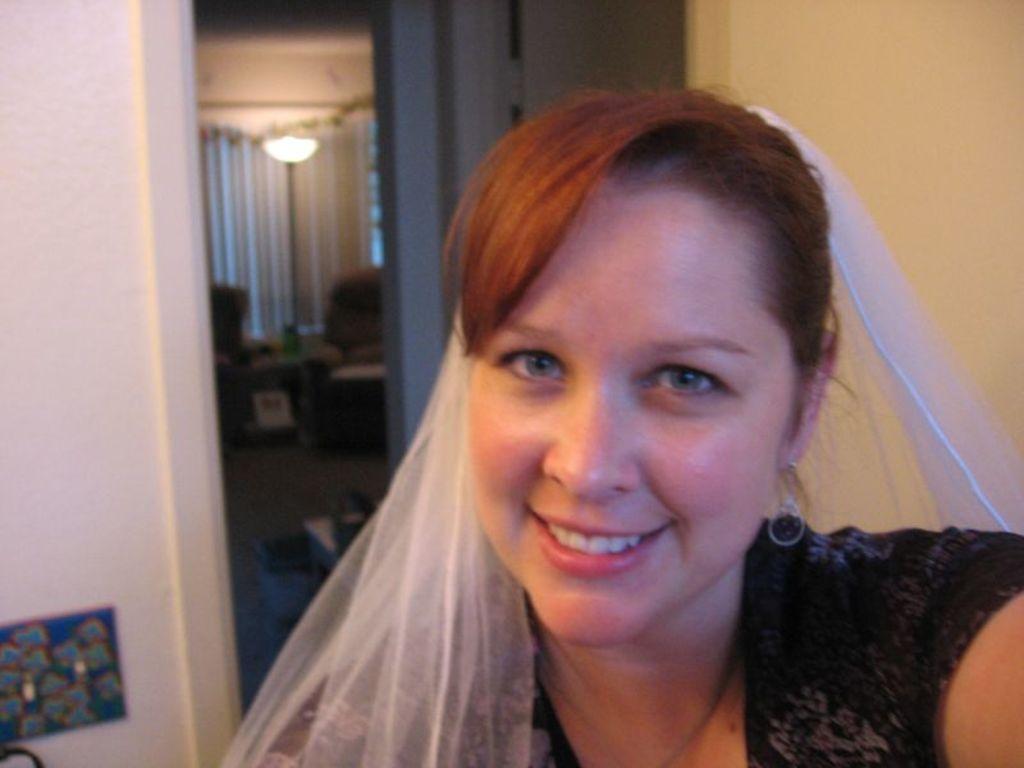Please provide a concise description of this image. In the picture there is a woman laughing, there is a wall, there is a door, there are chairs present, there are lights. 